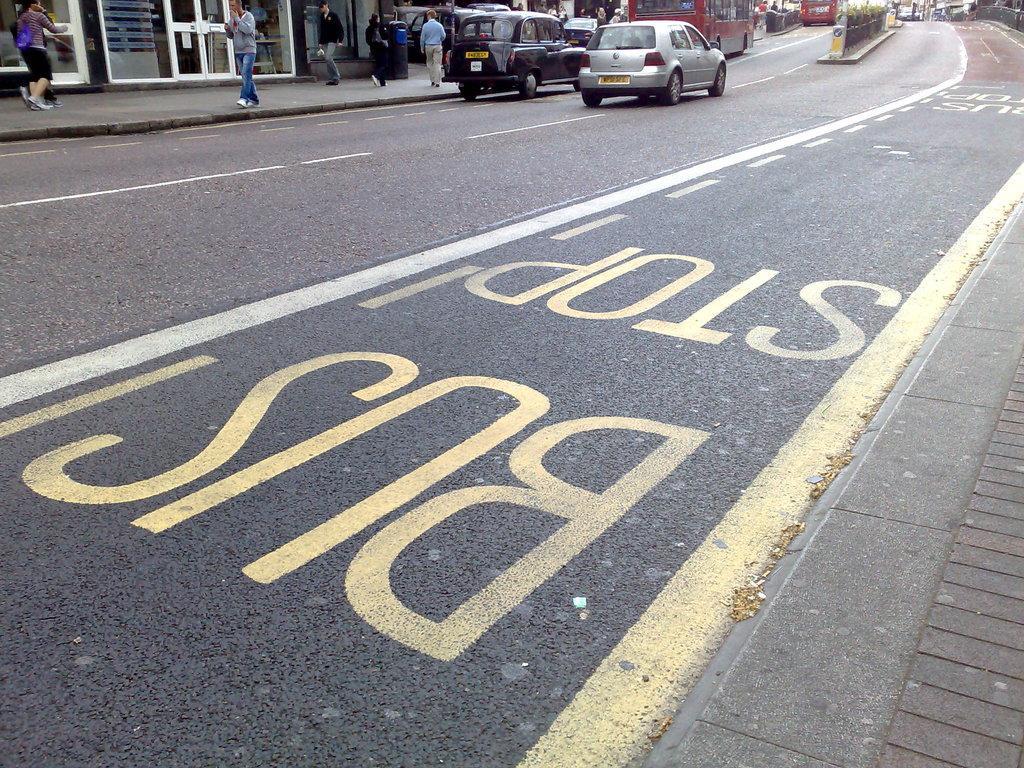Please provide a concise description of this image. In this image there is a road in the middle. On the road there are so many vehicles. On the left side top there is a footpath on which there are few people walking. Beside the footpath there are buildings. On the right side top there is a divider in between the road. At the bottom there is some text on the road. 